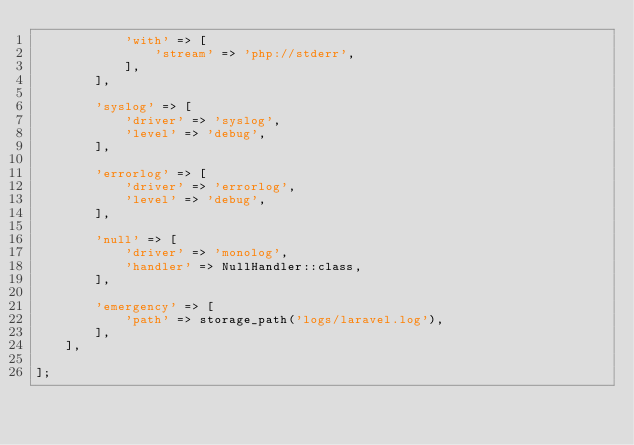<code> <loc_0><loc_0><loc_500><loc_500><_PHP_>            'with' => [
                'stream' => 'php://stderr',
            ],
        ],

        'syslog' => [
            'driver' => 'syslog',
            'level' => 'debug',
        ],

        'errorlog' => [
            'driver' => 'errorlog',
            'level' => 'debug',
        ],

        'null' => [
            'driver' => 'monolog',
            'handler' => NullHandler::class,
        ],

        'emergency' => [
            'path' => storage_path('logs/laravel.log'),
        ],
    ],

];
</code> 